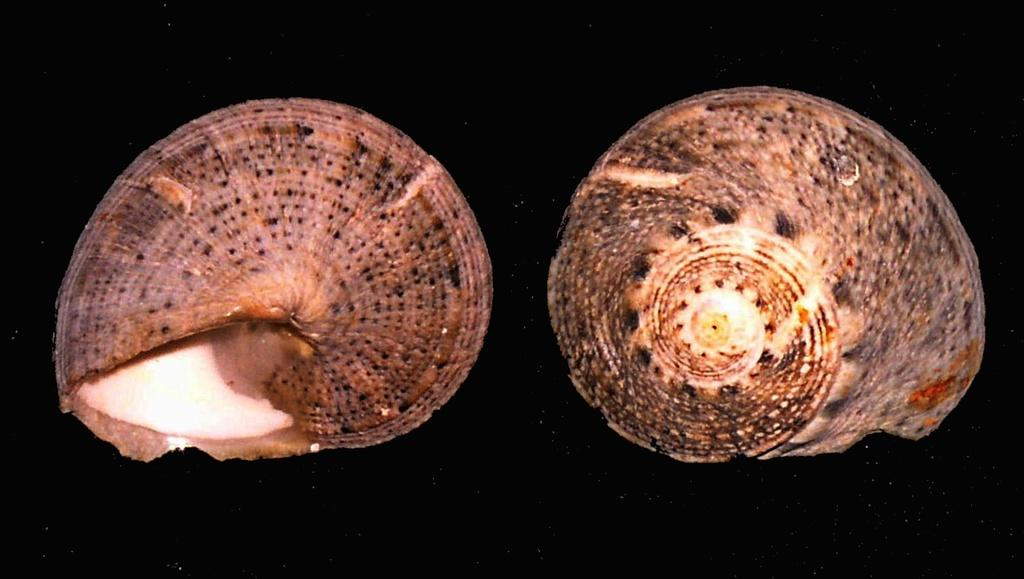What objects are present in the image? There are two snail shells in the image. What color is the background of the image? The background of the image is black. What type of cloth is draped over the snail shells in the image? There is no cloth present in the image; it only features two snail shells against a black background. What sound can be heard coming from the snail shells in the image? There is no sound present in the image, as it only contains two snail shells and a black background. 